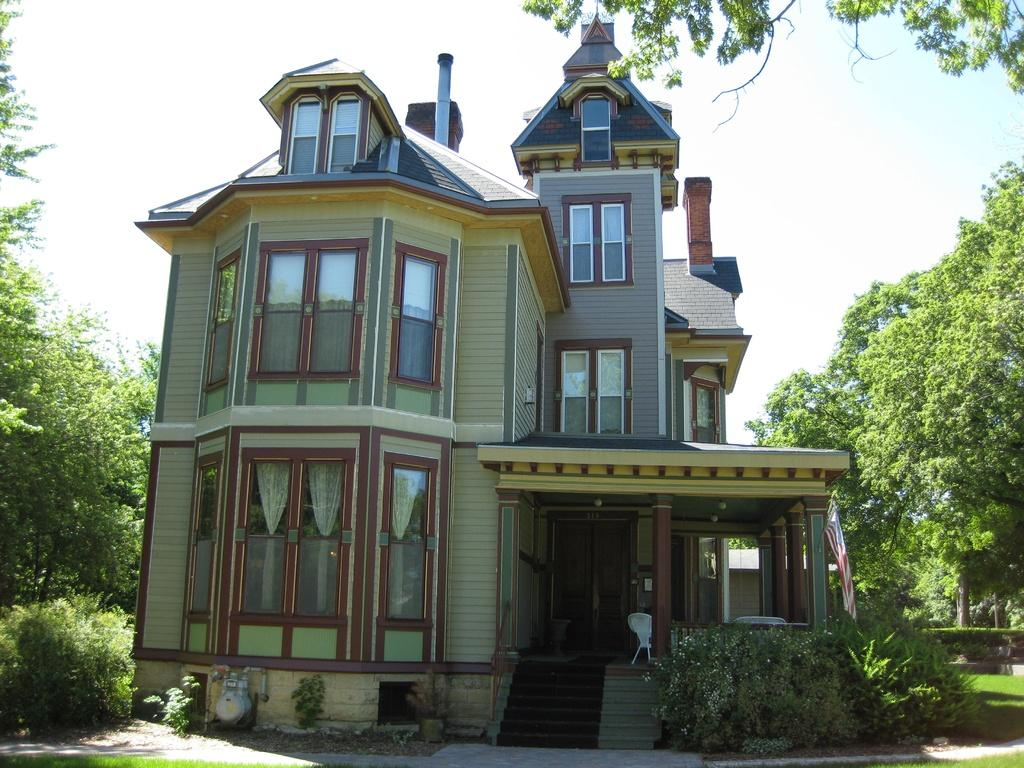What type of house is shown in the image? There is a house with glass windows in the image. What can be seen on both sides of the house? There are trees on either side of the image. What is visible at the top of the image? The sky is visible at the top of the image. What type of trousers are hanging on the clothesline in the image? There are no trousers or clothesline present in the image. What type of humor can be seen in the image? There is no humor depicted in the image; it is a simple scene of a house with trees and sky. 